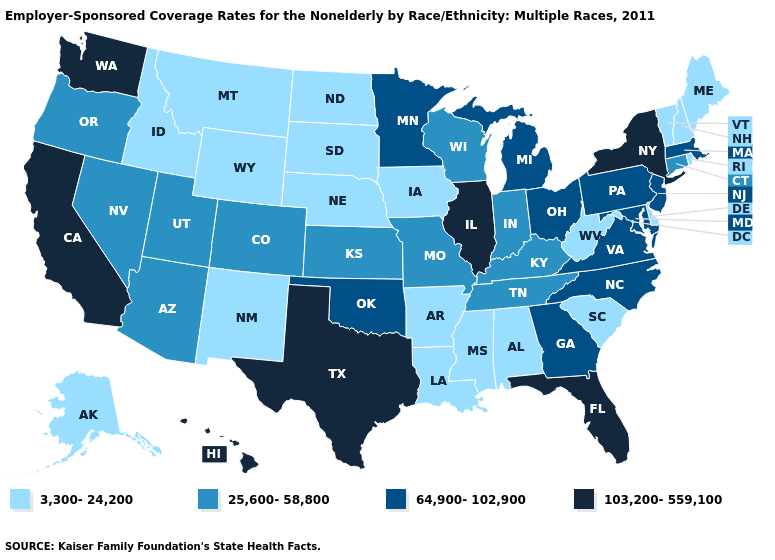What is the value of West Virginia?
Write a very short answer. 3,300-24,200. What is the value of Illinois?
Quick response, please. 103,200-559,100. Does Iowa have the lowest value in the MidWest?
Answer briefly. Yes. What is the highest value in the MidWest ?
Short answer required. 103,200-559,100. Does the map have missing data?
Give a very brief answer. No. Which states hav the highest value in the MidWest?
Keep it brief. Illinois. What is the lowest value in states that border Florida?
Quick response, please. 3,300-24,200. Which states have the highest value in the USA?
Short answer required. California, Florida, Hawaii, Illinois, New York, Texas, Washington. Name the states that have a value in the range 25,600-58,800?
Answer briefly. Arizona, Colorado, Connecticut, Indiana, Kansas, Kentucky, Missouri, Nevada, Oregon, Tennessee, Utah, Wisconsin. What is the highest value in the USA?
Write a very short answer. 103,200-559,100. What is the value of Nebraska?
Write a very short answer. 3,300-24,200. Name the states that have a value in the range 3,300-24,200?
Be succinct. Alabama, Alaska, Arkansas, Delaware, Idaho, Iowa, Louisiana, Maine, Mississippi, Montana, Nebraska, New Hampshire, New Mexico, North Dakota, Rhode Island, South Carolina, South Dakota, Vermont, West Virginia, Wyoming. Does Utah have a higher value than Illinois?
Short answer required. No. How many symbols are there in the legend?
Answer briefly. 4. 